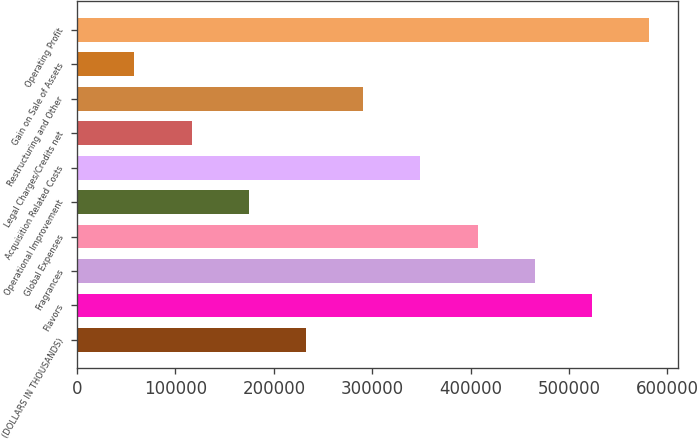Convert chart to OTSL. <chart><loc_0><loc_0><loc_500><loc_500><bar_chart><fcel>(DOLLARS IN THOUSANDS)<fcel>Flavors<fcel>Fragrances<fcel>Global Expenses<fcel>Operational Improvement<fcel>Acquisition Related Costs<fcel>Legal Charges/Credits net<fcel>Restructuring and Other<fcel>Gain on Sale of Assets<fcel>Operating Profit<nl><fcel>232587<fcel>523300<fcel>465158<fcel>407015<fcel>174445<fcel>348873<fcel>116302<fcel>290730<fcel>58159.7<fcel>581443<nl></chart> 